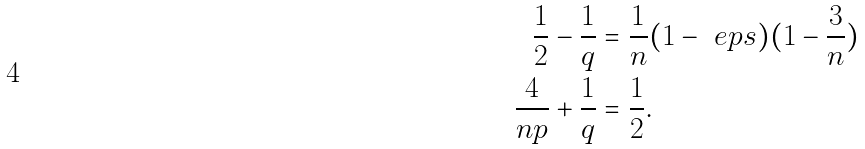Convert formula to latex. <formula><loc_0><loc_0><loc_500><loc_500>\frac { 1 } { 2 } - \frac { 1 } { q } & = \frac { 1 } { n } ( 1 - \ e p s ) ( 1 - \frac { 3 } { n } ) \\ \frac { 4 } { n p } + \frac { 1 } { q } & = \frac { 1 } { 2 } .</formula> 